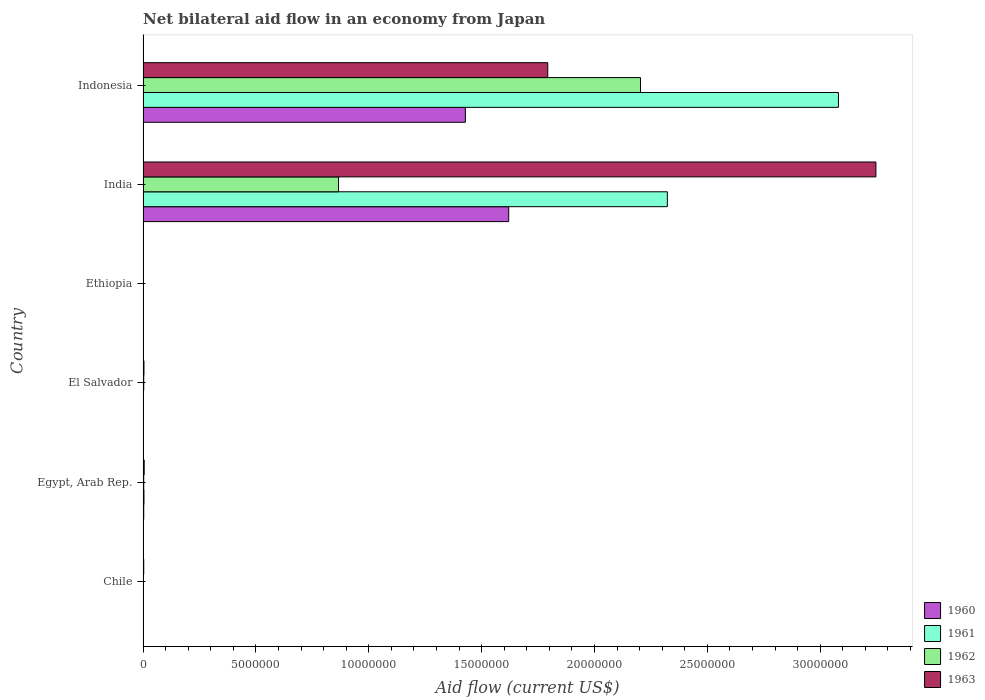What is the label of the 3rd group of bars from the top?
Keep it short and to the point. Ethiopia. In how many cases, is the number of bars for a given country not equal to the number of legend labels?
Make the answer very short. 0. What is the net bilateral aid flow in 1960 in El Salvador?
Ensure brevity in your answer.  10000. Across all countries, what is the maximum net bilateral aid flow in 1960?
Give a very brief answer. 1.62e+07. Across all countries, what is the minimum net bilateral aid flow in 1961?
Make the answer very short. 10000. In which country was the net bilateral aid flow in 1963 maximum?
Offer a terse response. India. In which country was the net bilateral aid flow in 1961 minimum?
Offer a very short reply. Chile. What is the total net bilateral aid flow in 1960 in the graph?
Keep it short and to the point. 3.05e+07. What is the difference between the net bilateral aid flow in 1962 in Chile and that in India?
Your answer should be very brief. -8.64e+06. What is the difference between the net bilateral aid flow in 1963 in Indonesia and the net bilateral aid flow in 1961 in Ethiopia?
Offer a terse response. 1.79e+07. What is the average net bilateral aid flow in 1960 per country?
Your response must be concise. 5.09e+06. In how many countries, is the net bilateral aid flow in 1963 greater than 30000000 US$?
Your answer should be compact. 1. Is the net bilateral aid flow in 1963 in El Salvador less than that in Indonesia?
Provide a succinct answer. Yes. What is the difference between the highest and the second highest net bilateral aid flow in 1961?
Give a very brief answer. 7.58e+06. What is the difference between the highest and the lowest net bilateral aid flow in 1961?
Provide a succinct answer. 3.08e+07. Is it the case that in every country, the sum of the net bilateral aid flow in 1963 and net bilateral aid flow in 1962 is greater than the sum of net bilateral aid flow in 1961 and net bilateral aid flow in 1960?
Ensure brevity in your answer.  No. What does the 3rd bar from the top in India represents?
Your answer should be compact. 1961. What does the 3rd bar from the bottom in Chile represents?
Ensure brevity in your answer.  1962. How many countries are there in the graph?
Keep it short and to the point. 6. Does the graph contain grids?
Your response must be concise. No. Where does the legend appear in the graph?
Provide a succinct answer. Bottom right. What is the title of the graph?
Provide a succinct answer. Net bilateral aid flow in an economy from Japan. What is the label or title of the X-axis?
Your answer should be compact. Aid flow (current US$). What is the Aid flow (current US$) in 1963 in Chile?
Give a very brief answer. 3.00e+04. What is the Aid flow (current US$) in 1961 in Egypt, Arab Rep.?
Your answer should be compact. 4.00e+04. What is the Aid flow (current US$) in 1963 in Egypt, Arab Rep.?
Provide a short and direct response. 5.00e+04. What is the Aid flow (current US$) in 1960 in El Salvador?
Provide a succinct answer. 10000. What is the Aid flow (current US$) of 1962 in El Salvador?
Keep it short and to the point. 3.00e+04. What is the Aid flow (current US$) in 1963 in El Salvador?
Your answer should be compact. 4.00e+04. What is the Aid flow (current US$) of 1961 in Ethiopia?
Your answer should be compact. 10000. What is the Aid flow (current US$) in 1962 in Ethiopia?
Provide a short and direct response. 10000. What is the Aid flow (current US$) of 1963 in Ethiopia?
Keep it short and to the point. 10000. What is the Aid flow (current US$) in 1960 in India?
Ensure brevity in your answer.  1.62e+07. What is the Aid flow (current US$) of 1961 in India?
Offer a very short reply. 2.32e+07. What is the Aid flow (current US$) in 1962 in India?
Offer a very short reply. 8.66e+06. What is the Aid flow (current US$) in 1963 in India?
Provide a short and direct response. 3.25e+07. What is the Aid flow (current US$) of 1960 in Indonesia?
Your answer should be very brief. 1.43e+07. What is the Aid flow (current US$) of 1961 in Indonesia?
Make the answer very short. 3.08e+07. What is the Aid flow (current US$) of 1962 in Indonesia?
Provide a short and direct response. 2.20e+07. What is the Aid flow (current US$) in 1963 in Indonesia?
Make the answer very short. 1.79e+07. Across all countries, what is the maximum Aid flow (current US$) of 1960?
Your response must be concise. 1.62e+07. Across all countries, what is the maximum Aid flow (current US$) of 1961?
Provide a short and direct response. 3.08e+07. Across all countries, what is the maximum Aid flow (current US$) of 1962?
Offer a very short reply. 2.20e+07. Across all countries, what is the maximum Aid flow (current US$) in 1963?
Make the answer very short. 3.25e+07. Across all countries, what is the minimum Aid flow (current US$) of 1960?
Your answer should be compact. 10000. Across all countries, what is the minimum Aid flow (current US$) of 1961?
Give a very brief answer. 10000. What is the total Aid flow (current US$) of 1960 in the graph?
Make the answer very short. 3.05e+07. What is the total Aid flow (current US$) of 1961 in the graph?
Offer a terse response. 5.41e+07. What is the total Aid flow (current US$) in 1962 in the graph?
Give a very brief answer. 3.08e+07. What is the total Aid flow (current US$) in 1963 in the graph?
Provide a short and direct response. 5.05e+07. What is the difference between the Aid flow (current US$) of 1960 in Chile and that in Egypt, Arab Rep.?
Offer a very short reply. -2.00e+04. What is the difference between the Aid flow (current US$) in 1961 in Chile and that in Egypt, Arab Rep.?
Your response must be concise. -3.00e+04. What is the difference between the Aid flow (current US$) of 1960 in Chile and that in El Salvador?
Ensure brevity in your answer.  0. What is the difference between the Aid flow (current US$) in 1963 in Chile and that in El Salvador?
Ensure brevity in your answer.  -10000. What is the difference between the Aid flow (current US$) in 1961 in Chile and that in Ethiopia?
Your answer should be very brief. 0. What is the difference between the Aid flow (current US$) of 1960 in Chile and that in India?
Make the answer very short. -1.62e+07. What is the difference between the Aid flow (current US$) of 1961 in Chile and that in India?
Your answer should be compact. -2.32e+07. What is the difference between the Aid flow (current US$) of 1962 in Chile and that in India?
Give a very brief answer. -8.64e+06. What is the difference between the Aid flow (current US$) of 1963 in Chile and that in India?
Provide a succinct answer. -3.24e+07. What is the difference between the Aid flow (current US$) in 1960 in Chile and that in Indonesia?
Offer a terse response. -1.43e+07. What is the difference between the Aid flow (current US$) of 1961 in Chile and that in Indonesia?
Your answer should be very brief. -3.08e+07. What is the difference between the Aid flow (current US$) in 1962 in Chile and that in Indonesia?
Your answer should be compact. -2.20e+07. What is the difference between the Aid flow (current US$) in 1963 in Chile and that in Indonesia?
Provide a short and direct response. -1.79e+07. What is the difference between the Aid flow (current US$) in 1961 in Egypt, Arab Rep. and that in El Salvador?
Your answer should be very brief. 3.00e+04. What is the difference between the Aid flow (current US$) of 1962 in Egypt, Arab Rep. and that in Ethiopia?
Your answer should be compact. 2.00e+04. What is the difference between the Aid flow (current US$) in 1963 in Egypt, Arab Rep. and that in Ethiopia?
Ensure brevity in your answer.  4.00e+04. What is the difference between the Aid flow (current US$) of 1960 in Egypt, Arab Rep. and that in India?
Offer a terse response. -1.62e+07. What is the difference between the Aid flow (current US$) of 1961 in Egypt, Arab Rep. and that in India?
Provide a short and direct response. -2.32e+07. What is the difference between the Aid flow (current US$) in 1962 in Egypt, Arab Rep. and that in India?
Make the answer very short. -8.63e+06. What is the difference between the Aid flow (current US$) in 1963 in Egypt, Arab Rep. and that in India?
Provide a short and direct response. -3.24e+07. What is the difference between the Aid flow (current US$) in 1960 in Egypt, Arab Rep. and that in Indonesia?
Offer a very short reply. -1.42e+07. What is the difference between the Aid flow (current US$) in 1961 in Egypt, Arab Rep. and that in Indonesia?
Provide a short and direct response. -3.08e+07. What is the difference between the Aid flow (current US$) of 1962 in Egypt, Arab Rep. and that in Indonesia?
Give a very brief answer. -2.20e+07. What is the difference between the Aid flow (current US$) in 1963 in Egypt, Arab Rep. and that in Indonesia?
Your answer should be compact. -1.79e+07. What is the difference between the Aid flow (current US$) of 1963 in El Salvador and that in Ethiopia?
Your response must be concise. 3.00e+04. What is the difference between the Aid flow (current US$) in 1960 in El Salvador and that in India?
Ensure brevity in your answer.  -1.62e+07. What is the difference between the Aid flow (current US$) in 1961 in El Salvador and that in India?
Your answer should be compact. -2.32e+07. What is the difference between the Aid flow (current US$) of 1962 in El Salvador and that in India?
Your answer should be compact. -8.63e+06. What is the difference between the Aid flow (current US$) of 1963 in El Salvador and that in India?
Your answer should be compact. -3.24e+07. What is the difference between the Aid flow (current US$) of 1960 in El Salvador and that in Indonesia?
Ensure brevity in your answer.  -1.43e+07. What is the difference between the Aid flow (current US$) of 1961 in El Salvador and that in Indonesia?
Offer a very short reply. -3.08e+07. What is the difference between the Aid flow (current US$) in 1962 in El Salvador and that in Indonesia?
Offer a very short reply. -2.20e+07. What is the difference between the Aid flow (current US$) of 1963 in El Salvador and that in Indonesia?
Ensure brevity in your answer.  -1.79e+07. What is the difference between the Aid flow (current US$) in 1960 in Ethiopia and that in India?
Your answer should be compact. -1.62e+07. What is the difference between the Aid flow (current US$) in 1961 in Ethiopia and that in India?
Provide a short and direct response. -2.32e+07. What is the difference between the Aid flow (current US$) in 1962 in Ethiopia and that in India?
Provide a short and direct response. -8.65e+06. What is the difference between the Aid flow (current US$) in 1963 in Ethiopia and that in India?
Make the answer very short. -3.25e+07. What is the difference between the Aid flow (current US$) of 1960 in Ethiopia and that in Indonesia?
Provide a succinct answer. -1.43e+07. What is the difference between the Aid flow (current US$) of 1961 in Ethiopia and that in Indonesia?
Keep it short and to the point. -3.08e+07. What is the difference between the Aid flow (current US$) of 1962 in Ethiopia and that in Indonesia?
Keep it short and to the point. -2.20e+07. What is the difference between the Aid flow (current US$) in 1963 in Ethiopia and that in Indonesia?
Give a very brief answer. -1.79e+07. What is the difference between the Aid flow (current US$) in 1960 in India and that in Indonesia?
Your answer should be compact. 1.92e+06. What is the difference between the Aid flow (current US$) in 1961 in India and that in Indonesia?
Your answer should be very brief. -7.58e+06. What is the difference between the Aid flow (current US$) in 1962 in India and that in Indonesia?
Offer a terse response. -1.34e+07. What is the difference between the Aid flow (current US$) in 1963 in India and that in Indonesia?
Give a very brief answer. 1.45e+07. What is the difference between the Aid flow (current US$) of 1960 in Chile and the Aid flow (current US$) of 1961 in Egypt, Arab Rep.?
Make the answer very short. -3.00e+04. What is the difference between the Aid flow (current US$) in 1960 in Chile and the Aid flow (current US$) in 1963 in Egypt, Arab Rep.?
Your answer should be compact. -4.00e+04. What is the difference between the Aid flow (current US$) of 1962 in Chile and the Aid flow (current US$) of 1963 in Egypt, Arab Rep.?
Ensure brevity in your answer.  -3.00e+04. What is the difference between the Aid flow (current US$) of 1960 in Chile and the Aid flow (current US$) of 1961 in El Salvador?
Your answer should be compact. 0. What is the difference between the Aid flow (current US$) in 1960 in Chile and the Aid flow (current US$) in 1962 in El Salvador?
Offer a terse response. -2.00e+04. What is the difference between the Aid flow (current US$) in 1961 in Chile and the Aid flow (current US$) in 1962 in El Salvador?
Provide a short and direct response. -2.00e+04. What is the difference between the Aid flow (current US$) of 1961 in Chile and the Aid flow (current US$) of 1963 in El Salvador?
Your answer should be compact. -3.00e+04. What is the difference between the Aid flow (current US$) in 1960 in Chile and the Aid flow (current US$) in 1961 in Ethiopia?
Keep it short and to the point. 0. What is the difference between the Aid flow (current US$) of 1960 in Chile and the Aid flow (current US$) of 1963 in Ethiopia?
Your response must be concise. 0. What is the difference between the Aid flow (current US$) of 1961 in Chile and the Aid flow (current US$) of 1963 in Ethiopia?
Offer a terse response. 0. What is the difference between the Aid flow (current US$) in 1962 in Chile and the Aid flow (current US$) in 1963 in Ethiopia?
Give a very brief answer. 10000. What is the difference between the Aid flow (current US$) in 1960 in Chile and the Aid flow (current US$) in 1961 in India?
Your answer should be very brief. -2.32e+07. What is the difference between the Aid flow (current US$) of 1960 in Chile and the Aid flow (current US$) of 1962 in India?
Ensure brevity in your answer.  -8.65e+06. What is the difference between the Aid flow (current US$) of 1960 in Chile and the Aid flow (current US$) of 1963 in India?
Your answer should be very brief. -3.25e+07. What is the difference between the Aid flow (current US$) of 1961 in Chile and the Aid flow (current US$) of 1962 in India?
Give a very brief answer. -8.65e+06. What is the difference between the Aid flow (current US$) in 1961 in Chile and the Aid flow (current US$) in 1963 in India?
Provide a short and direct response. -3.25e+07. What is the difference between the Aid flow (current US$) in 1962 in Chile and the Aid flow (current US$) in 1963 in India?
Ensure brevity in your answer.  -3.24e+07. What is the difference between the Aid flow (current US$) in 1960 in Chile and the Aid flow (current US$) in 1961 in Indonesia?
Your answer should be compact. -3.08e+07. What is the difference between the Aid flow (current US$) of 1960 in Chile and the Aid flow (current US$) of 1962 in Indonesia?
Provide a succinct answer. -2.20e+07. What is the difference between the Aid flow (current US$) of 1960 in Chile and the Aid flow (current US$) of 1963 in Indonesia?
Ensure brevity in your answer.  -1.79e+07. What is the difference between the Aid flow (current US$) of 1961 in Chile and the Aid flow (current US$) of 1962 in Indonesia?
Your answer should be very brief. -2.20e+07. What is the difference between the Aid flow (current US$) of 1961 in Chile and the Aid flow (current US$) of 1963 in Indonesia?
Keep it short and to the point. -1.79e+07. What is the difference between the Aid flow (current US$) in 1962 in Chile and the Aid flow (current US$) in 1963 in Indonesia?
Keep it short and to the point. -1.79e+07. What is the difference between the Aid flow (current US$) in 1961 in Egypt, Arab Rep. and the Aid flow (current US$) in 1963 in El Salvador?
Provide a succinct answer. 0. What is the difference between the Aid flow (current US$) in 1962 in Egypt, Arab Rep. and the Aid flow (current US$) in 1963 in El Salvador?
Ensure brevity in your answer.  -10000. What is the difference between the Aid flow (current US$) of 1960 in Egypt, Arab Rep. and the Aid flow (current US$) of 1961 in Ethiopia?
Your answer should be compact. 2.00e+04. What is the difference between the Aid flow (current US$) in 1960 in Egypt, Arab Rep. and the Aid flow (current US$) in 1962 in Ethiopia?
Your response must be concise. 2.00e+04. What is the difference between the Aid flow (current US$) of 1960 in Egypt, Arab Rep. and the Aid flow (current US$) of 1963 in Ethiopia?
Provide a short and direct response. 2.00e+04. What is the difference between the Aid flow (current US$) of 1961 in Egypt, Arab Rep. and the Aid flow (current US$) of 1962 in Ethiopia?
Ensure brevity in your answer.  3.00e+04. What is the difference between the Aid flow (current US$) in 1961 in Egypt, Arab Rep. and the Aid flow (current US$) in 1963 in Ethiopia?
Give a very brief answer. 3.00e+04. What is the difference between the Aid flow (current US$) of 1962 in Egypt, Arab Rep. and the Aid flow (current US$) of 1963 in Ethiopia?
Your answer should be compact. 2.00e+04. What is the difference between the Aid flow (current US$) of 1960 in Egypt, Arab Rep. and the Aid flow (current US$) of 1961 in India?
Provide a succinct answer. -2.32e+07. What is the difference between the Aid flow (current US$) in 1960 in Egypt, Arab Rep. and the Aid flow (current US$) in 1962 in India?
Your answer should be compact. -8.63e+06. What is the difference between the Aid flow (current US$) of 1960 in Egypt, Arab Rep. and the Aid flow (current US$) of 1963 in India?
Your answer should be very brief. -3.24e+07. What is the difference between the Aid flow (current US$) in 1961 in Egypt, Arab Rep. and the Aid flow (current US$) in 1962 in India?
Offer a terse response. -8.62e+06. What is the difference between the Aid flow (current US$) in 1961 in Egypt, Arab Rep. and the Aid flow (current US$) in 1963 in India?
Give a very brief answer. -3.24e+07. What is the difference between the Aid flow (current US$) of 1962 in Egypt, Arab Rep. and the Aid flow (current US$) of 1963 in India?
Your answer should be very brief. -3.24e+07. What is the difference between the Aid flow (current US$) in 1960 in Egypt, Arab Rep. and the Aid flow (current US$) in 1961 in Indonesia?
Your answer should be compact. -3.08e+07. What is the difference between the Aid flow (current US$) in 1960 in Egypt, Arab Rep. and the Aid flow (current US$) in 1962 in Indonesia?
Your response must be concise. -2.20e+07. What is the difference between the Aid flow (current US$) of 1960 in Egypt, Arab Rep. and the Aid flow (current US$) of 1963 in Indonesia?
Provide a succinct answer. -1.79e+07. What is the difference between the Aid flow (current US$) in 1961 in Egypt, Arab Rep. and the Aid flow (current US$) in 1962 in Indonesia?
Provide a succinct answer. -2.20e+07. What is the difference between the Aid flow (current US$) of 1961 in Egypt, Arab Rep. and the Aid flow (current US$) of 1963 in Indonesia?
Keep it short and to the point. -1.79e+07. What is the difference between the Aid flow (current US$) of 1962 in Egypt, Arab Rep. and the Aid flow (current US$) of 1963 in Indonesia?
Your response must be concise. -1.79e+07. What is the difference between the Aid flow (current US$) in 1960 in El Salvador and the Aid flow (current US$) in 1963 in Ethiopia?
Offer a very short reply. 0. What is the difference between the Aid flow (current US$) of 1961 in El Salvador and the Aid flow (current US$) of 1962 in Ethiopia?
Keep it short and to the point. 0. What is the difference between the Aid flow (current US$) of 1960 in El Salvador and the Aid flow (current US$) of 1961 in India?
Ensure brevity in your answer.  -2.32e+07. What is the difference between the Aid flow (current US$) in 1960 in El Salvador and the Aid flow (current US$) in 1962 in India?
Provide a succinct answer. -8.65e+06. What is the difference between the Aid flow (current US$) of 1960 in El Salvador and the Aid flow (current US$) of 1963 in India?
Provide a short and direct response. -3.25e+07. What is the difference between the Aid flow (current US$) of 1961 in El Salvador and the Aid flow (current US$) of 1962 in India?
Offer a very short reply. -8.65e+06. What is the difference between the Aid flow (current US$) in 1961 in El Salvador and the Aid flow (current US$) in 1963 in India?
Offer a terse response. -3.25e+07. What is the difference between the Aid flow (current US$) in 1962 in El Salvador and the Aid flow (current US$) in 1963 in India?
Your answer should be compact. -3.24e+07. What is the difference between the Aid flow (current US$) in 1960 in El Salvador and the Aid flow (current US$) in 1961 in Indonesia?
Your response must be concise. -3.08e+07. What is the difference between the Aid flow (current US$) of 1960 in El Salvador and the Aid flow (current US$) of 1962 in Indonesia?
Your answer should be compact. -2.20e+07. What is the difference between the Aid flow (current US$) in 1960 in El Salvador and the Aid flow (current US$) in 1963 in Indonesia?
Offer a terse response. -1.79e+07. What is the difference between the Aid flow (current US$) in 1961 in El Salvador and the Aid flow (current US$) in 1962 in Indonesia?
Your answer should be compact. -2.20e+07. What is the difference between the Aid flow (current US$) in 1961 in El Salvador and the Aid flow (current US$) in 1963 in Indonesia?
Ensure brevity in your answer.  -1.79e+07. What is the difference between the Aid flow (current US$) of 1962 in El Salvador and the Aid flow (current US$) of 1963 in Indonesia?
Offer a terse response. -1.79e+07. What is the difference between the Aid flow (current US$) of 1960 in Ethiopia and the Aid flow (current US$) of 1961 in India?
Give a very brief answer. -2.32e+07. What is the difference between the Aid flow (current US$) in 1960 in Ethiopia and the Aid flow (current US$) in 1962 in India?
Give a very brief answer. -8.65e+06. What is the difference between the Aid flow (current US$) of 1960 in Ethiopia and the Aid flow (current US$) of 1963 in India?
Offer a very short reply. -3.25e+07. What is the difference between the Aid flow (current US$) of 1961 in Ethiopia and the Aid flow (current US$) of 1962 in India?
Ensure brevity in your answer.  -8.65e+06. What is the difference between the Aid flow (current US$) in 1961 in Ethiopia and the Aid flow (current US$) in 1963 in India?
Keep it short and to the point. -3.25e+07. What is the difference between the Aid flow (current US$) in 1962 in Ethiopia and the Aid flow (current US$) in 1963 in India?
Make the answer very short. -3.25e+07. What is the difference between the Aid flow (current US$) in 1960 in Ethiopia and the Aid flow (current US$) in 1961 in Indonesia?
Provide a short and direct response. -3.08e+07. What is the difference between the Aid flow (current US$) of 1960 in Ethiopia and the Aid flow (current US$) of 1962 in Indonesia?
Provide a short and direct response. -2.20e+07. What is the difference between the Aid flow (current US$) in 1960 in Ethiopia and the Aid flow (current US$) in 1963 in Indonesia?
Your answer should be compact. -1.79e+07. What is the difference between the Aid flow (current US$) of 1961 in Ethiopia and the Aid flow (current US$) of 1962 in Indonesia?
Give a very brief answer. -2.20e+07. What is the difference between the Aid flow (current US$) of 1961 in Ethiopia and the Aid flow (current US$) of 1963 in Indonesia?
Provide a succinct answer. -1.79e+07. What is the difference between the Aid flow (current US$) in 1962 in Ethiopia and the Aid flow (current US$) in 1963 in Indonesia?
Ensure brevity in your answer.  -1.79e+07. What is the difference between the Aid flow (current US$) of 1960 in India and the Aid flow (current US$) of 1961 in Indonesia?
Your answer should be very brief. -1.46e+07. What is the difference between the Aid flow (current US$) in 1960 in India and the Aid flow (current US$) in 1962 in Indonesia?
Offer a terse response. -5.84e+06. What is the difference between the Aid flow (current US$) of 1960 in India and the Aid flow (current US$) of 1963 in Indonesia?
Your answer should be compact. -1.73e+06. What is the difference between the Aid flow (current US$) in 1961 in India and the Aid flow (current US$) in 1962 in Indonesia?
Keep it short and to the point. 1.19e+06. What is the difference between the Aid flow (current US$) of 1961 in India and the Aid flow (current US$) of 1963 in Indonesia?
Make the answer very short. 5.30e+06. What is the difference between the Aid flow (current US$) in 1962 in India and the Aid flow (current US$) in 1963 in Indonesia?
Your answer should be very brief. -9.27e+06. What is the average Aid flow (current US$) in 1960 per country?
Make the answer very short. 5.09e+06. What is the average Aid flow (current US$) of 1961 per country?
Make the answer very short. 9.02e+06. What is the average Aid flow (current US$) in 1962 per country?
Give a very brief answer. 5.13e+06. What is the average Aid flow (current US$) of 1963 per country?
Your answer should be compact. 8.42e+06. What is the difference between the Aid flow (current US$) of 1961 and Aid flow (current US$) of 1962 in Chile?
Your answer should be compact. -10000. What is the difference between the Aid flow (current US$) of 1960 and Aid flow (current US$) of 1961 in Egypt, Arab Rep.?
Give a very brief answer. -10000. What is the difference between the Aid flow (current US$) in 1960 and Aid flow (current US$) in 1963 in Egypt, Arab Rep.?
Keep it short and to the point. -2.00e+04. What is the difference between the Aid flow (current US$) in 1961 and Aid flow (current US$) in 1962 in Egypt, Arab Rep.?
Your answer should be very brief. 10000. What is the difference between the Aid flow (current US$) of 1960 and Aid flow (current US$) of 1962 in El Salvador?
Your response must be concise. -2.00e+04. What is the difference between the Aid flow (current US$) in 1960 and Aid flow (current US$) in 1963 in El Salvador?
Make the answer very short. -3.00e+04. What is the difference between the Aid flow (current US$) of 1961 and Aid flow (current US$) of 1963 in El Salvador?
Offer a very short reply. -3.00e+04. What is the difference between the Aid flow (current US$) in 1961 and Aid flow (current US$) in 1962 in Ethiopia?
Your answer should be very brief. 0. What is the difference between the Aid flow (current US$) of 1962 and Aid flow (current US$) of 1963 in Ethiopia?
Give a very brief answer. 0. What is the difference between the Aid flow (current US$) in 1960 and Aid flow (current US$) in 1961 in India?
Your answer should be very brief. -7.03e+06. What is the difference between the Aid flow (current US$) in 1960 and Aid flow (current US$) in 1962 in India?
Offer a terse response. 7.54e+06. What is the difference between the Aid flow (current US$) of 1960 and Aid flow (current US$) of 1963 in India?
Offer a terse response. -1.63e+07. What is the difference between the Aid flow (current US$) in 1961 and Aid flow (current US$) in 1962 in India?
Make the answer very short. 1.46e+07. What is the difference between the Aid flow (current US$) of 1961 and Aid flow (current US$) of 1963 in India?
Offer a very short reply. -9.24e+06. What is the difference between the Aid flow (current US$) in 1962 and Aid flow (current US$) in 1963 in India?
Provide a short and direct response. -2.38e+07. What is the difference between the Aid flow (current US$) in 1960 and Aid flow (current US$) in 1961 in Indonesia?
Provide a short and direct response. -1.65e+07. What is the difference between the Aid flow (current US$) in 1960 and Aid flow (current US$) in 1962 in Indonesia?
Offer a very short reply. -7.76e+06. What is the difference between the Aid flow (current US$) in 1960 and Aid flow (current US$) in 1963 in Indonesia?
Ensure brevity in your answer.  -3.65e+06. What is the difference between the Aid flow (current US$) of 1961 and Aid flow (current US$) of 1962 in Indonesia?
Offer a terse response. 8.77e+06. What is the difference between the Aid flow (current US$) of 1961 and Aid flow (current US$) of 1963 in Indonesia?
Your answer should be compact. 1.29e+07. What is the difference between the Aid flow (current US$) of 1962 and Aid flow (current US$) of 1963 in Indonesia?
Offer a very short reply. 4.11e+06. What is the ratio of the Aid flow (current US$) of 1962 in Chile to that in Egypt, Arab Rep.?
Offer a terse response. 0.67. What is the ratio of the Aid flow (current US$) in 1961 in Chile to that in El Salvador?
Give a very brief answer. 1. What is the ratio of the Aid flow (current US$) of 1960 in Chile to that in Ethiopia?
Provide a succinct answer. 1. What is the ratio of the Aid flow (current US$) of 1963 in Chile to that in Ethiopia?
Keep it short and to the point. 3. What is the ratio of the Aid flow (current US$) in 1960 in Chile to that in India?
Provide a short and direct response. 0. What is the ratio of the Aid flow (current US$) in 1962 in Chile to that in India?
Give a very brief answer. 0. What is the ratio of the Aid flow (current US$) of 1963 in Chile to that in India?
Make the answer very short. 0. What is the ratio of the Aid flow (current US$) in 1960 in Chile to that in Indonesia?
Your answer should be compact. 0. What is the ratio of the Aid flow (current US$) in 1962 in Chile to that in Indonesia?
Your response must be concise. 0. What is the ratio of the Aid flow (current US$) of 1963 in Chile to that in Indonesia?
Offer a terse response. 0. What is the ratio of the Aid flow (current US$) of 1961 in Egypt, Arab Rep. to that in El Salvador?
Your answer should be compact. 4. What is the ratio of the Aid flow (current US$) in 1960 in Egypt, Arab Rep. to that in Ethiopia?
Offer a terse response. 3. What is the ratio of the Aid flow (current US$) of 1961 in Egypt, Arab Rep. to that in Ethiopia?
Your answer should be very brief. 4. What is the ratio of the Aid flow (current US$) in 1962 in Egypt, Arab Rep. to that in Ethiopia?
Offer a very short reply. 3. What is the ratio of the Aid flow (current US$) in 1963 in Egypt, Arab Rep. to that in Ethiopia?
Your answer should be compact. 5. What is the ratio of the Aid flow (current US$) of 1960 in Egypt, Arab Rep. to that in India?
Make the answer very short. 0. What is the ratio of the Aid flow (current US$) in 1961 in Egypt, Arab Rep. to that in India?
Ensure brevity in your answer.  0. What is the ratio of the Aid flow (current US$) in 1962 in Egypt, Arab Rep. to that in India?
Offer a very short reply. 0. What is the ratio of the Aid flow (current US$) of 1963 in Egypt, Arab Rep. to that in India?
Offer a terse response. 0. What is the ratio of the Aid flow (current US$) of 1960 in Egypt, Arab Rep. to that in Indonesia?
Make the answer very short. 0. What is the ratio of the Aid flow (current US$) in 1961 in Egypt, Arab Rep. to that in Indonesia?
Provide a succinct answer. 0. What is the ratio of the Aid flow (current US$) in 1962 in Egypt, Arab Rep. to that in Indonesia?
Your answer should be compact. 0. What is the ratio of the Aid flow (current US$) in 1963 in Egypt, Arab Rep. to that in Indonesia?
Give a very brief answer. 0. What is the ratio of the Aid flow (current US$) in 1961 in El Salvador to that in Ethiopia?
Your response must be concise. 1. What is the ratio of the Aid flow (current US$) of 1963 in El Salvador to that in Ethiopia?
Offer a terse response. 4. What is the ratio of the Aid flow (current US$) in 1960 in El Salvador to that in India?
Your answer should be very brief. 0. What is the ratio of the Aid flow (current US$) of 1962 in El Salvador to that in India?
Ensure brevity in your answer.  0. What is the ratio of the Aid flow (current US$) of 1963 in El Salvador to that in India?
Offer a very short reply. 0. What is the ratio of the Aid flow (current US$) in 1960 in El Salvador to that in Indonesia?
Make the answer very short. 0. What is the ratio of the Aid flow (current US$) in 1961 in El Salvador to that in Indonesia?
Offer a terse response. 0. What is the ratio of the Aid flow (current US$) in 1962 in El Salvador to that in Indonesia?
Your response must be concise. 0. What is the ratio of the Aid flow (current US$) of 1963 in El Salvador to that in Indonesia?
Keep it short and to the point. 0. What is the ratio of the Aid flow (current US$) in 1960 in Ethiopia to that in India?
Your response must be concise. 0. What is the ratio of the Aid flow (current US$) in 1961 in Ethiopia to that in India?
Your answer should be very brief. 0. What is the ratio of the Aid flow (current US$) of 1962 in Ethiopia to that in India?
Provide a succinct answer. 0. What is the ratio of the Aid flow (current US$) in 1963 in Ethiopia to that in India?
Your response must be concise. 0. What is the ratio of the Aid flow (current US$) in 1960 in Ethiopia to that in Indonesia?
Provide a short and direct response. 0. What is the ratio of the Aid flow (current US$) of 1962 in Ethiopia to that in Indonesia?
Provide a succinct answer. 0. What is the ratio of the Aid flow (current US$) of 1963 in Ethiopia to that in Indonesia?
Make the answer very short. 0. What is the ratio of the Aid flow (current US$) in 1960 in India to that in Indonesia?
Give a very brief answer. 1.13. What is the ratio of the Aid flow (current US$) in 1961 in India to that in Indonesia?
Ensure brevity in your answer.  0.75. What is the ratio of the Aid flow (current US$) in 1962 in India to that in Indonesia?
Offer a terse response. 0.39. What is the ratio of the Aid flow (current US$) in 1963 in India to that in Indonesia?
Your answer should be very brief. 1.81. What is the difference between the highest and the second highest Aid flow (current US$) in 1960?
Give a very brief answer. 1.92e+06. What is the difference between the highest and the second highest Aid flow (current US$) in 1961?
Your answer should be compact. 7.58e+06. What is the difference between the highest and the second highest Aid flow (current US$) of 1962?
Your answer should be very brief. 1.34e+07. What is the difference between the highest and the second highest Aid flow (current US$) in 1963?
Give a very brief answer. 1.45e+07. What is the difference between the highest and the lowest Aid flow (current US$) of 1960?
Provide a short and direct response. 1.62e+07. What is the difference between the highest and the lowest Aid flow (current US$) in 1961?
Keep it short and to the point. 3.08e+07. What is the difference between the highest and the lowest Aid flow (current US$) in 1962?
Your answer should be very brief. 2.20e+07. What is the difference between the highest and the lowest Aid flow (current US$) in 1963?
Ensure brevity in your answer.  3.25e+07. 